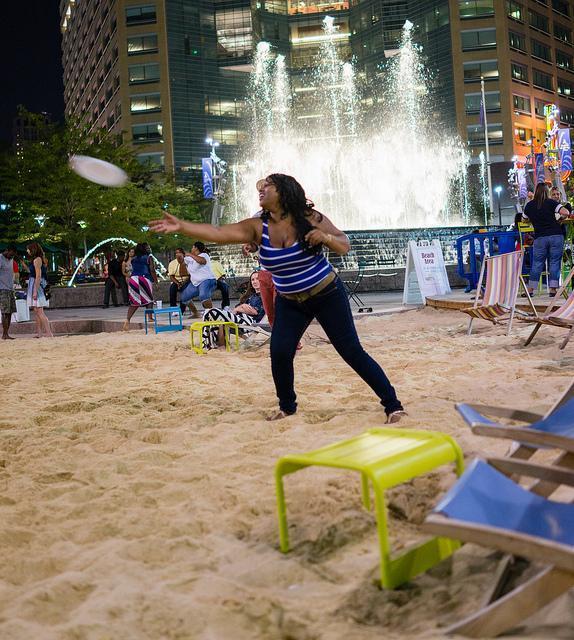How many women are playing a sport?
Give a very brief answer. 1. How many people are there?
Give a very brief answer. 2. How many chairs can be seen?
Give a very brief answer. 3. 